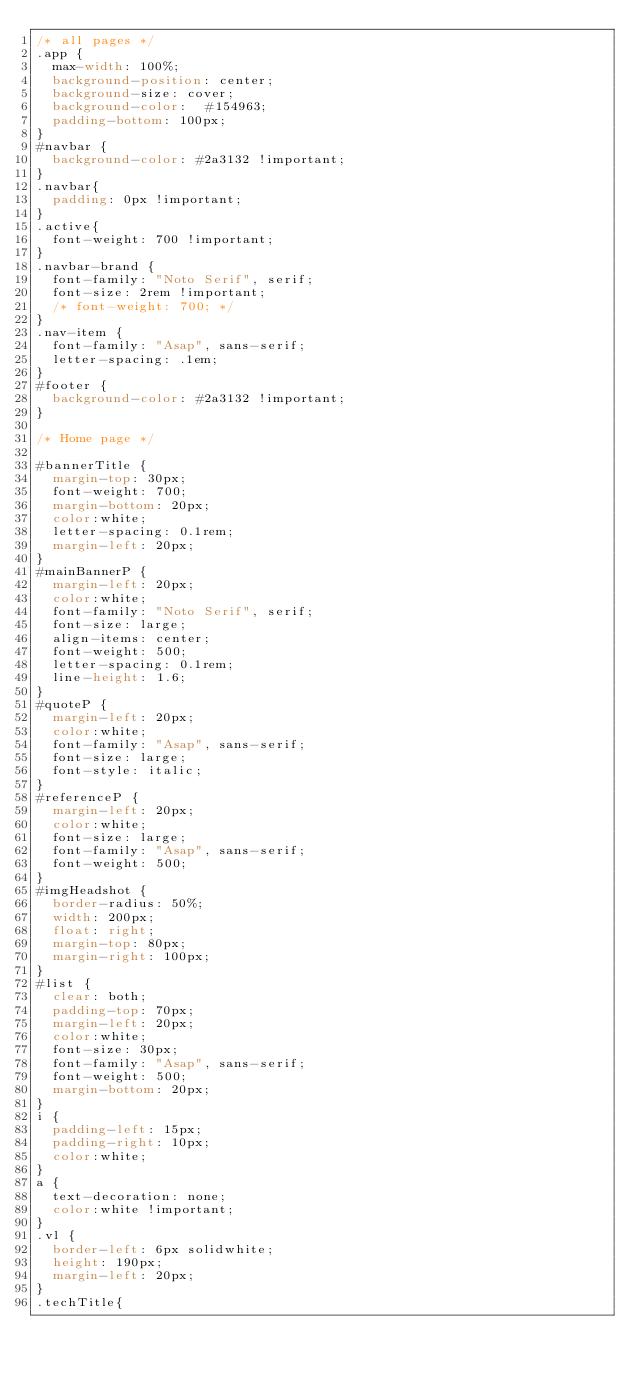Convert code to text. <code><loc_0><loc_0><loc_500><loc_500><_CSS_>/* all pages */
.app {
  max-width: 100%;
  background-position: center;
  background-size: cover;
  background-color:  #154963;
  padding-bottom: 100px;
}
#navbar {
  background-color: #2a3132 !important;
}
.navbar{
  padding: 0px !important;
}
.active{
  font-weight: 700 !important;
}
.navbar-brand {
  font-family: "Noto Serif", serif;
  font-size: 2rem !important;
  /* font-weight: 700; */
}
.nav-item {
  font-family: "Asap", sans-serif;
  letter-spacing: .1em;
}
#footer {
  background-color: #2a3132 !important;
}

/* Home page */

#bannerTitle {
  margin-top: 30px;
  font-weight: 700;
  margin-bottom: 20px;
  color:white;
  letter-spacing: 0.1rem;
  margin-left: 20px;
}
#mainBannerP {
  margin-left: 20px;
  color:white;
  font-family: "Noto Serif", serif;
  font-size: large;
  align-items: center;
  font-weight: 500;
  letter-spacing: 0.1rem;
  line-height: 1.6;
}
#quoteP {
  margin-left: 20px;
  color:white;
  font-family: "Asap", sans-serif;
  font-size: large;
  font-style: italic;
}
#referenceP {
  margin-left: 20px;
  color:white;
  font-size: large;
  font-family: "Asap", sans-serif;
  font-weight: 500;
}
#imgHeadshot {
  border-radius: 50%;
  width: 200px;
  float: right;
  margin-top: 80px;
  margin-right: 100px;
}
#list {
  clear: both;
  padding-top: 70px;
  margin-left: 20px;
  color:white;
  font-size: 30px;
  font-family: "Asap", sans-serif;
  font-weight: 500;
  margin-bottom: 20px;
}
i {
  padding-left: 15px;
  padding-right: 10px;
  color:white;
}
a {
  text-decoration: none;
  color:white !important;
}
.vl {
  border-left: 6px solidwhite;
  height: 190px;
  margin-left: 20px;
}
.techTitle{</code> 